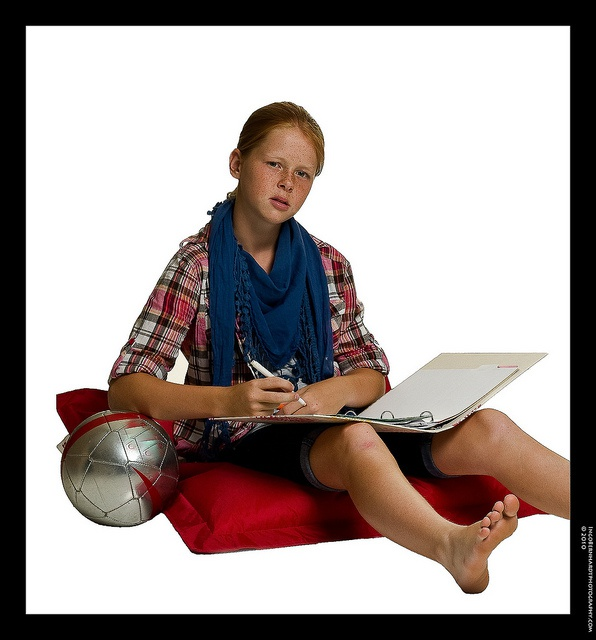Describe the objects in this image and their specific colors. I can see people in black, brown, maroon, and navy tones, sports ball in black, darkgray, gray, and maroon tones, and book in black, lightgray, and darkgray tones in this image. 